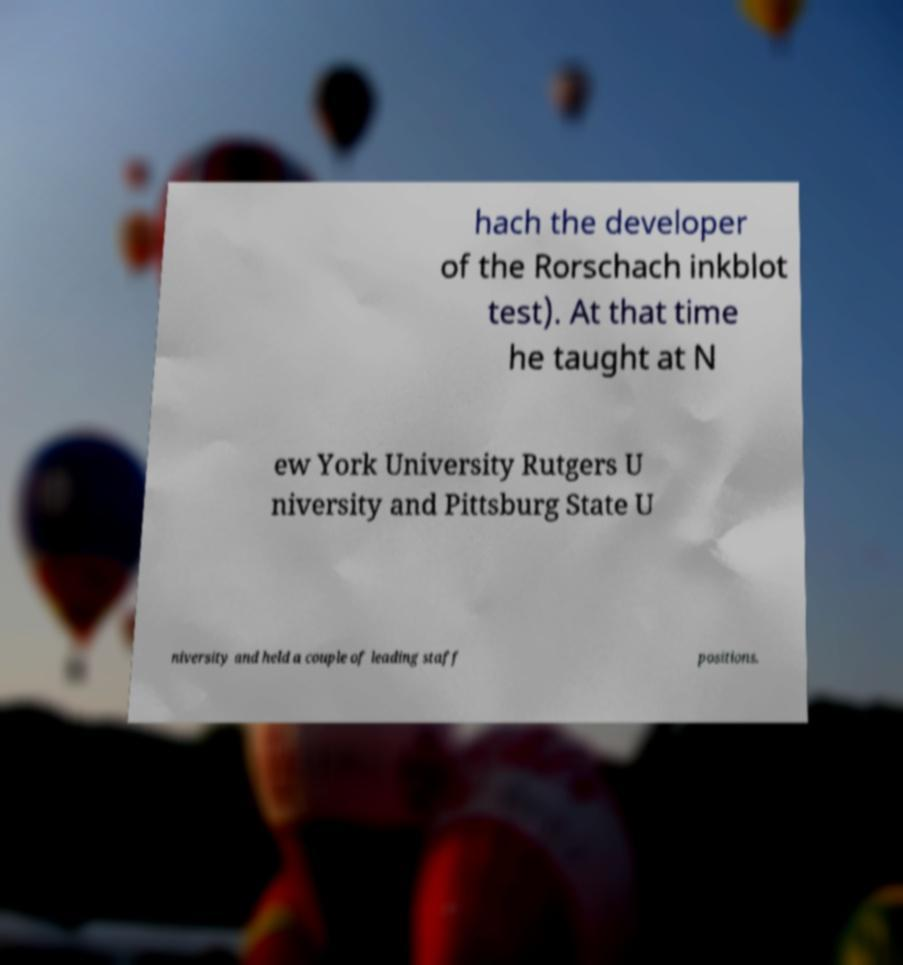What messages or text are displayed in this image? I need them in a readable, typed format. hach the developer of the Rorschach inkblot test). At that time he taught at N ew York University Rutgers U niversity and Pittsburg State U niversity and held a couple of leading staff positions. 